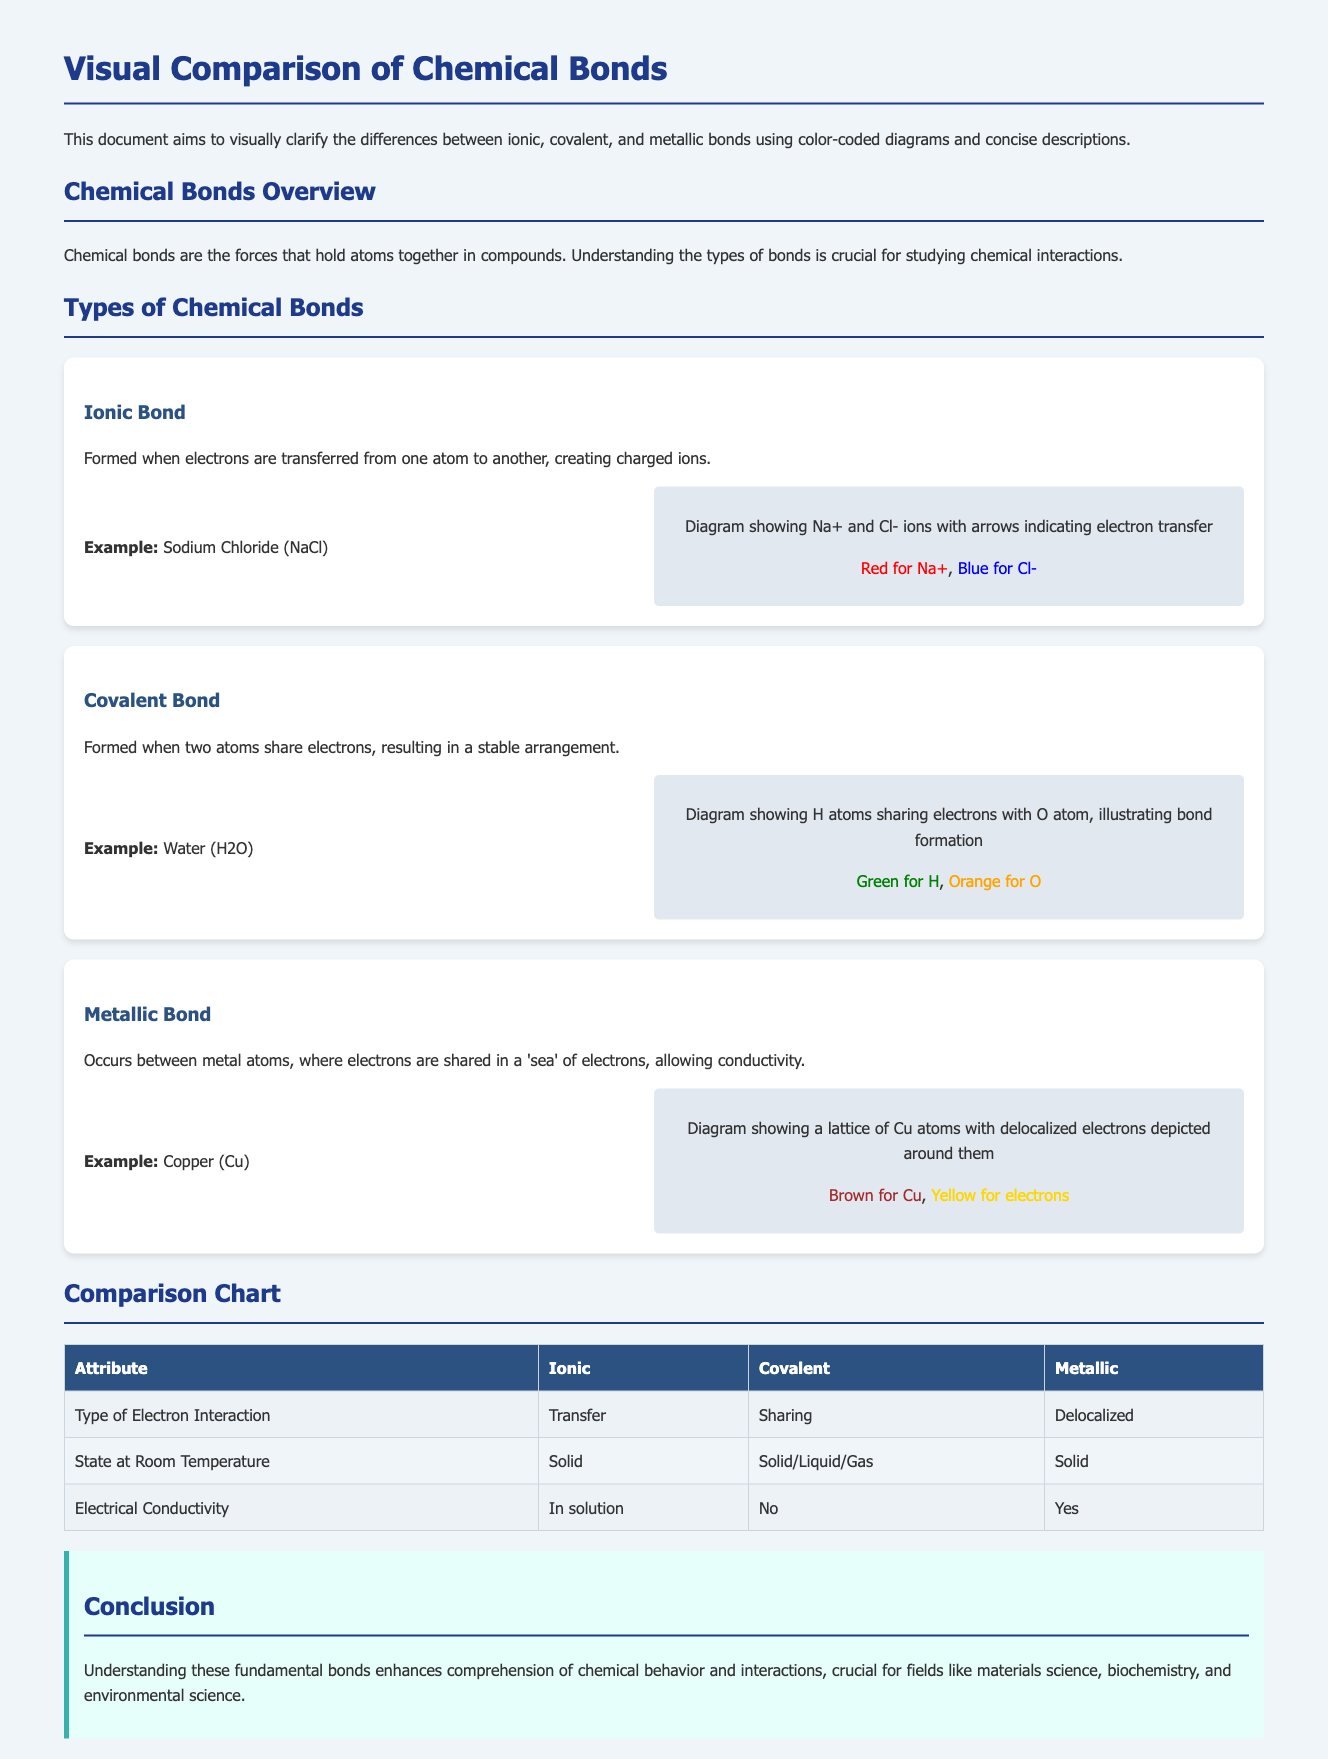What is the first type of chemical bond mentioned? The first type of chemical bond discussed in the document is "Ionic Bond."
Answer: Ionic Bond What is the color used for Sodium in the ionic bond diagram? The document specifies that the color used for Sodium (Na+) is red.
Answer: Red What type of bond involves sharing electrons? The bond type that involves sharing electrons is called "Covalent Bond."
Answer: Covalent Bond Which bond type demonstrates an example of Copper? The example involving Copper belongs to the "Metallic Bond."
Answer: Metallic Bond What is the electrical conductivity state for ionic bonds? The document states that ionic bonds conduct electricity "In solution."
Answer: In solution What is the arrangement state of covalent bonds at room temperature? According to the document, covalent bonds can be in a "Solid/Liquid/Gas" state at room temperature.
Answer: Solid/Liquid/Gas How are the electrons described in metallic bonds? The electrons in metallic bonds are described as "Delocalized."
Answer: Delocalized What is the background color for the conclusion section? The background color for the conclusion section is "e6fffa."
Answer: e6fffa How many bond types are visually explained in the document? The document visually explains three bond types: ionic, covalent, and metallic.
Answer: Three 